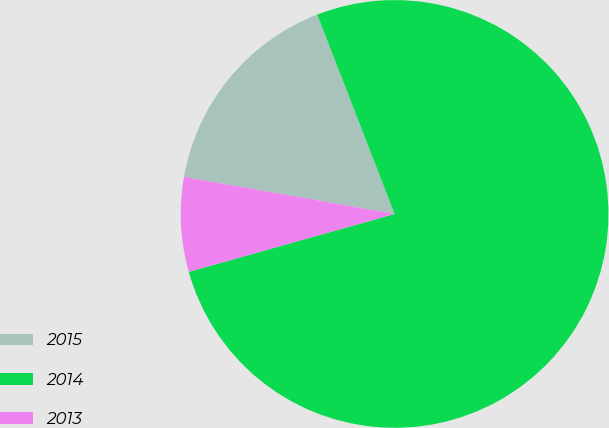<chart> <loc_0><loc_0><loc_500><loc_500><pie_chart><fcel>2015<fcel>2014<fcel>2013<nl><fcel>16.33%<fcel>76.53%<fcel>7.14%<nl></chart> 